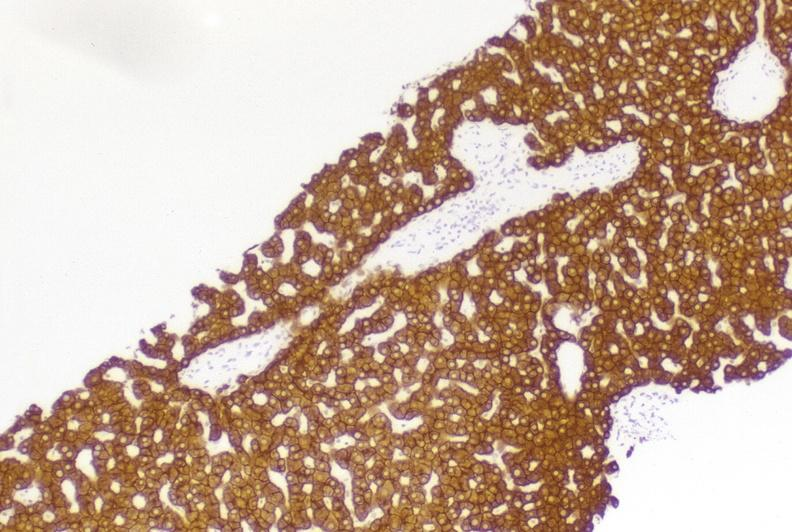what does this image show?
Answer the question using a single word or phrase. High molecular weight keratin 